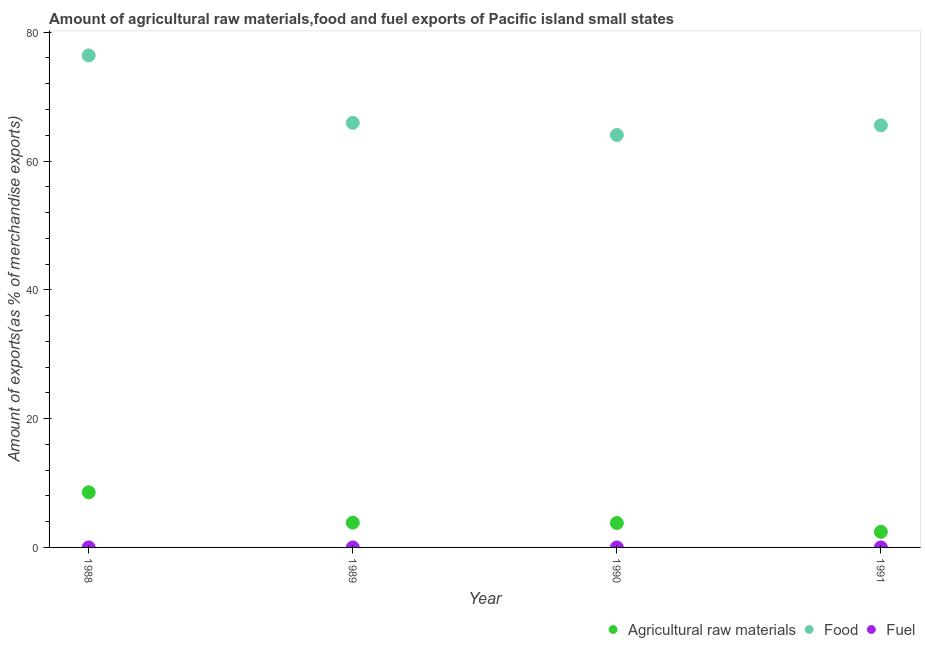What is the percentage of fuel exports in 1991?
Ensure brevity in your answer.  0. Across all years, what is the maximum percentage of food exports?
Give a very brief answer. 76.4. Across all years, what is the minimum percentage of fuel exports?
Your response must be concise. 3.98845700657726e-5. In which year was the percentage of fuel exports maximum?
Your response must be concise. 1991. What is the total percentage of raw materials exports in the graph?
Keep it short and to the point. 18.62. What is the difference between the percentage of food exports in 1990 and that in 1991?
Offer a very short reply. -1.5. What is the difference between the percentage of food exports in 1988 and the percentage of fuel exports in 1991?
Your response must be concise. 76.4. What is the average percentage of raw materials exports per year?
Make the answer very short. 4.65. In the year 1988, what is the difference between the percentage of food exports and percentage of fuel exports?
Provide a succinct answer. 76.4. In how many years, is the percentage of food exports greater than 32 %?
Your response must be concise. 4. What is the ratio of the percentage of raw materials exports in 1988 to that in 1989?
Your response must be concise. 2.23. Is the percentage of raw materials exports in 1988 less than that in 1989?
Your answer should be compact. No. Is the difference between the percentage of raw materials exports in 1989 and 1991 greater than the difference between the percentage of food exports in 1989 and 1991?
Provide a succinct answer. Yes. What is the difference between the highest and the second highest percentage of fuel exports?
Your answer should be compact. 0. What is the difference between the highest and the lowest percentage of fuel exports?
Make the answer very short. 0. Is the sum of the percentage of fuel exports in 1989 and 1991 greater than the maximum percentage of food exports across all years?
Offer a terse response. No. Is it the case that in every year, the sum of the percentage of raw materials exports and percentage of food exports is greater than the percentage of fuel exports?
Provide a succinct answer. Yes. How many years are there in the graph?
Your response must be concise. 4. What is the difference between two consecutive major ticks on the Y-axis?
Your response must be concise. 20. Does the graph contain any zero values?
Your response must be concise. No. How many legend labels are there?
Make the answer very short. 3. What is the title of the graph?
Your answer should be very brief. Amount of agricultural raw materials,food and fuel exports of Pacific island small states. What is the label or title of the X-axis?
Offer a very short reply. Year. What is the label or title of the Y-axis?
Give a very brief answer. Amount of exports(as % of merchandise exports). What is the Amount of exports(as % of merchandise exports) in Agricultural raw materials in 1988?
Provide a succinct answer. 8.56. What is the Amount of exports(as % of merchandise exports) in Food in 1988?
Make the answer very short. 76.4. What is the Amount of exports(as % of merchandise exports) of Fuel in 1988?
Your response must be concise. 0. What is the Amount of exports(as % of merchandise exports) in Agricultural raw materials in 1989?
Your answer should be compact. 3.84. What is the Amount of exports(as % of merchandise exports) in Food in 1989?
Keep it short and to the point. 65.93. What is the Amount of exports(as % of merchandise exports) of Fuel in 1989?
Offer a very short reply. 3.98845700657726e-5. What is the Amount of exports(as % of merchandise exports) in Agricultural raw materials in 1990?
Provide a succinct answer. 3.79. What is the Amount of exports(as % of merchandise exports) of Food in 1990?
Offer a terse response. 64.04. What is the Amount of exports(as % of merchandise exports) in Fuel in 1990?
Your answer should be compact. 0. What is the Amount of exports(as % of merchandise exports) of Agricultural raw materials in 1991?
Provide a short and direct response. 2.43. What is the Amount of exports(as % of merchandise exports) of Food in 1991?
Provide a short and direct response. 65.54. What is the Amount of exports(as % of merchandise exports) in Fuel in 1991?
Offer a very short reply. 0. Across all years, what is the maximum Amount of exports(as % of merchandise exports) of Agricultural raw materials?
Your answer should be compact. 8.56. Across all years, what is the maximum Amount of exports(as % of merchandise exports) of Food?
Give a very brief answer. 76.4. Across all years, what is the maximum Amount of exports(as % of merchandise exports) of Fuel?
Give a very brief answer. 0. Across all years, what is the minimum Amount of exports(as % of merchandise exports) in Agricultural raw materials?
Keep it short and to the point. 2.43. Across all years, what is the minimum Amount of exports(as % of merchandise exports) in Food?
Provide a short and direct response. 64.04. Across all years, what is the minimum Amount of exports(as % of merchandise exports) of Fuel?
Provide a short and direct response. 3.98845700657726e-5. What is the total Amount of exports(as % of merchandise exports) in Agricultural raw materials in the graph?
Your answer should be very brief. 18.62. What is the total Amount of exports(as % of merchandise exports) of Food in the graph?
Ensure brevity in your answer.  271.91. What is the total Amount of exports(as % of merchandise exports) of Fuel in the graph?
Give a very brief answer. 0.01. What is the difference between the Amount of exports(as % of merchandise exports) in Agricultural raw materials in 1988 and that in 1989?
Keep it short and to the point. 4.72. What is the difference between the Amount of exports(as % of merchandise exports) in Food in 1988 and that in 1989?
Your response must be concise. 10.46. What is the difference between the Amount of exports(as % of merchandise exports) of Agricultural raw materials in 1988 and that in 1990?
Ensure brevity in your answer.  4.77. What is the difference between the Amount of exports(as % of merchandise exports) of Food in 1988 and that in 1990?
Ensure brevity in your answer.  12.36. What is the difference between the Amount of exports(as % of merchandise exports) in Fuel in 1988 and that in 1990?
Give a very brief answer. -0. What is the difference between the Amount of exports(as % of merchandise exports) of Agricultural raw materials in 1988 and that in 1991?
Keep it short and to the point. 6.13. What is the difference between the Amount of exports(as % of merchandise exports) in Food in 1988 and that in 1991?
Provide a short and direct response. 10.86. What is the difference between the Amount of exports(as % of merchandise exports) in Fuel in 1988 and that in 1991?
Keep it short and to the point. -0. What is the difference between the Amount of exports(as % of merchandise exports) in Agricultural raw materials in 1989 and that in 1990?
Provide a short and direct response. 0.06. What is the difference between the Amount of exports(as % of merchandise exports) in Food in 1989 and that in 1990?
Ensure brevity in your answer.  1.89. What is the difference between the Amount of exports(as % of merchandise exports) in Fuel in 1989 and that in 1990?
Offer a terse response. -0. What is the difference between the Amount of exports(as % of merchandise exports) in Agricultural raw materials in 1989 and that in 1991?
Provide a short and direct response. 1.42. What is the difference between the Amount of exports(as % of merchandise exports) in Food in 1989 and that in 1991?
Ensure brevity in your answer.  0.4. What is the difference between the Amount of exports(as % of merchandise exports) of Fuel in 1989 and that in 1991?
Give a very brief answer. -0. What is the difference between the Amount of exports(as % of merchandise exports) of Agricultural raw materials in 1990 and that in 1991?
Ensure brevity in your answer.  1.36. What is the difference between the Amount of exports(as % of merchandise exports) of Food in 1990 and that in 1991?
Your answer should be compact. -1.5. What is the difference between the Amount of exports(as % of merchandise exports) in Fuel in 1990 and that in 1991?
Your answer should be compact. -0. What is the difference between the Amount of exports(as % of merchandise exports) of Agricultural raw materials in 1988 and the Amount of exports(as % of merchandise exports) of Food in 1989?
Offer a terse response. -57.37. What is the difference between the Amount of exports(as % of merchandise exports) in Agricultural raw materials in 1988 and the Amount of exports(as % of merchandise exports) in Fuel in 1989?
Offer a terse response. 8.56. What is the difference between the Amount of exports(as % of merchandise exports) of Food in 1988 and the Amount of exports(as % of merchandise exports) of Fuel in 1989?
Provide a succinct answer. 76.4. What is the difference between the Amount of exports(as % of merchandise exports) of Agricultural raw materials in 1988 and the Amount of exports(as % of merchandise exports) of Food in 1990?
Offer a terse response. -55.48. What is the difference between the Amount of exports(as % of merchandise exports) in Agricultural raw materials in 1988 and the Amount of exports(as % of merchandise exports) in Fuel in 1990?
Give a very brief answer. 8.56. What is the difference between the Amount of exports(as % of merchandise exports) in Food in 1988 and the Amount of exports(as % of merchandise exports) in Fuel in 1990?
Make the answer very short. 76.4. What is the difference between the Amount of exports(as % of merchandise exports) of Agricultural raw materials in 1988 and the Amount of exports(as % of merchandise exports) of Food in 1991?
Your answer should be very brief. -56.98. What is the difference between the Amount of exports(as % of merchandise exports) in Agricultural raw materials in 1988 and the Amount of exports(as % of merchandise exports) in Fuel in 1991?
Offer a very short reply. 8.56. What is the difference between the Amount of exports(as % of merchandise exports) in Food in 1988 and the Amount of exports(as % of merchandise exports) in Fuel in 1991?
Offer a terse response. 76.4. What is the difference between the Amount of exports(as % of merchandise exports) in Agricultural raw materials in 1989 and the Amount of exports(as % of merchandise exports) in Food in 1990?
Make the answer very short. -60.2. What is the difference between the Amount of exports(as % of merchandise exports) of Agricultural raw materials in 1989 and the Amount of exports(as % of merchandise exports) of Fuel in 1990?
Your answer should be compact. 3.84. What is the difference between the Amount of exports(as % of merchandise exports) in Food in 1989 and the Amount of exports(as % of merchandise exports) in Fuel in 1990?
Provide a succinct answer. 65.93. What is the difference between the Amount of exports(as % of merchandise exports) in Agricultural raw materials in 1989 and the Amount of exports(as % of merchandise exports) in Food in 1991?
Ensure brevity in your answer.  -61.69. What is the difference between the Amount of exports(as % of merchandise exports) in Agricultural raw materials in 1989 and the Amount of exports(as % of merchandise exports) in Fuel in 1991?
Your answer should be very brief. 3.84. What is the difference between the Amount of exports(as % of merchandise exports) of Food in 1989 and the Amount of exports(as % of merchandise exports) of Fuel in 1991?
Offer a very short reply. 65.93. What is the difference between the Amount of exports(as % of merchandise exports) of Agricultural raw materials in 1990 and the Amount of exports(as % of merchandise exports) of Food in 1991?
Provide a short and direct response. -61.75. What is the difference between the Amount of exports(as % of merchandise exports) of Agricultural raw materials in 1990 and the Amount of exports(as % of merchandise exports) of Fuel in 1991?
Keep it short and to the point. 3.79. What is the difference between the Amount of exports(as % of merchandise exports) in Food in 1990 and the Amount of exports(as % of merchandise exports) in Fuel in 1991?
Make the answer very short. 64.04. What is the average Amount of exports(as % of merchandise exports) in Agricultural raw materials per year?
Make the answer very short. 4.65. What is the average Amount of exports(as % of merchandise exports) of Food per year?
Make the answer very short. 67.98. What is the average Amount of exports(as % of merchandise exports) of Fuel per year?
Provide a succinct answer. 0. In the year 1988, what is the difference between the Amount of exports(as % of merchandise exports) of Agricultural raw materials and Amount of exports(as % of merchandise exports) of Food?
Your answer should be compact. -67.84. In the year 1988, what is the difference between the Amount of exports(as % of merchandise exports) of Agricultural raw materials and Amount of exports(as % of merchandise exports) of Fuel?
Provide a succinct answer. 8.56. In the year 1988, what is the difference between the Amount of exports(as % of merchandise exports) of Food and Amount of exports(as % of merchandise exports) of Fuel?
Give a very brief answer. 76.4. In the year 1989, what is the difference between the Amount of exports(as % of merchandise exports) of Agricultural raw materials and Amount of exports(as % of merchandise exports) of Food?
Offer a very short reply. -62.09. In the year 1989, what is the difference between the Amount of exports(as % of merchandise exports) in Agricultural raw materials and Amount of exports(as % of merchandise exports) in Fuel?
Keep it short and to the point. 3.84. In the year 1989, what is the difference between the Amount of exports(as % of merchandise exports) in Food and Amount of exports(as % of merchandise exports) in Fuel?
Your answer should be compact. 65.93. In the year 1990, what is the difference between the Amount of exports(as % of merchandise exports) in Agricultural raw materials and Amount of exports(as % of merchandise exports) in Food?
Your response must be concise. -60.25. In the year 1990, what is the difference between the Amount of exports(as % of merchandise exports) of Agricultural raw materials and Amount of exports(as % of merchandise exports) of Fuel?
Offer a very short reply. 3.79. In the year 1990, what is the difference between the Amount of exports(as % of merchandise exports) in Food and Amount of exports(as % of merchandise exports) in Fuel?
Offer a very short reply. 64.04. In the year 1991, what is the difference between the Amount of exports(as % of merchandise exports) in Agricultural raw materials and Amount of exports(as % of merchandise exports) in Food?
Your answer should be very brief. -63.11. In the year 1991, what is the difference between the Amount of exports(as % of merchandise exports) of Agricultural raw materials and Amount of exports(as % of merchandise exports) of Fuel?
Your answer should be compact. 2.42. In the year 1991, what is the difference between the Amount of exports(as % of merchandise exports) of Food and Amount of exports(as % of merchandise exports) of Fuel?
Offer a terse response. 65.53. What is the ratio of the Amount of exports(as % of merchandise exports) in Agricultural raw materials in 1988 to that in 1989?
Provide a short and direct response. 2.23. What is the ratio of the Amount of exports(as % of merchandise exports) in Food in 1988 to that in 1989?
Keep it short and to the point. 1.16. What is the ratio of the Amount of exports(as % of merchandise exports) in Fuel in 1988 to that in 1989?
Ensure brevity in your answer.  8.99. What is the ratio of the Amount of exports(as % of merchandise exports) of Agricultural raw materials in 1988 to that in 1990?
Offer a very short reply. 2.26. What is the ratio of the Amount of exports(as % of merchandise exports) in Food in 1988 to that in 1990?
Offer a terse response. 1.19. What is the ratio of the Amount of exports(as % of merchandise exports) of Fuel in 1988 to that in 1990?
Your answer should be very brief. 0.17. What is the ratio of the Amount of exports(as % of merchandise exports) of Agricultural raw materials in 1988 to that in 1991?
Make the answer very short. 3.53. What is the ratio of the Amount of exports(as % of merchandise exports) in Food in 1988 to that in 1991?
Provide a short and direct response. 1.17. What is the ratio of the Amount of exports(as % of merchandise exports) in Fuel in 1988 to that in 1991?
Offer a terse response. 0.11. What is the ratio of the Amount of exports(as % of merchandise exports) of Agricultural raw materials in 1989 to that in 1990?
Offer a terse response. 1.01. What is the ratio of the Amount of exports(as % of merchandise exports) in Food in 1989 to that in 1990?
Your answer should be compact. 1.03. What is the ratio of the Amount of exports(as % of merchandise exports) in Fuel in 1989 to that in 1990?
Give a very brief answer. 0.02. What is the ratio of the Amount of exports(as % of merchandise exports) in Agricultural raw materials in 1989 to that in 1991?
Offer a very short reply. 1.58. What is the ratio of the Amount of exports(as % of merchandise exports) of Food in 1989 to that in 1991?
Your answer should be compact. 1.01. What is the ratio of the Amount of exports(as % of merchandise exports) in Fuel in 1989 to that in 1991?
Give a very brief answer. 0.01. What is the ratio of the Amount of exports(as % of merchandise exports) in Agricultural raw materials in 1990 to that in 1991?
Provide a succinct answer. 1.56. What is the ratio of the Amount of exports(as % of merchandise exports) in Food in 1990 to that in 1991?
Offer a terse response. 0.98. What is the ratio of the Amount of exports(as % of merchandise exports) of Fuel in 1990 to that in 1991?
Provide a succinct answer. 0.63. What is the difference between the highest and the second highest Amount of exports(as % of merchandise exports) in Agricultural raw materials?
Your answer should be compact. 4.72. What is the difference between the highest and the second highest Amount of exports(as % of merchandise exports) in Food?
Your response must be concise. 10.46. What is the difference between the highest and the second highest Amount of exports(as % of merchandise exports) of Fuel?
Your response must be concise. 0. What is the difference between the highest and the lowest Amount of exports(as % of merchandise exports) of Agricultural raw materials?
Ensure brevity in your answer.  6.13. What is the difference between the highest and the lowest Amount of exports(as % of merchandise exports) of Food?
Offer a very short reply. 12.36. What is the difference between the highest and the lowest Amount of exports(as % of merchandise exports) of Fuel?
Your answer should be compact. 0. 